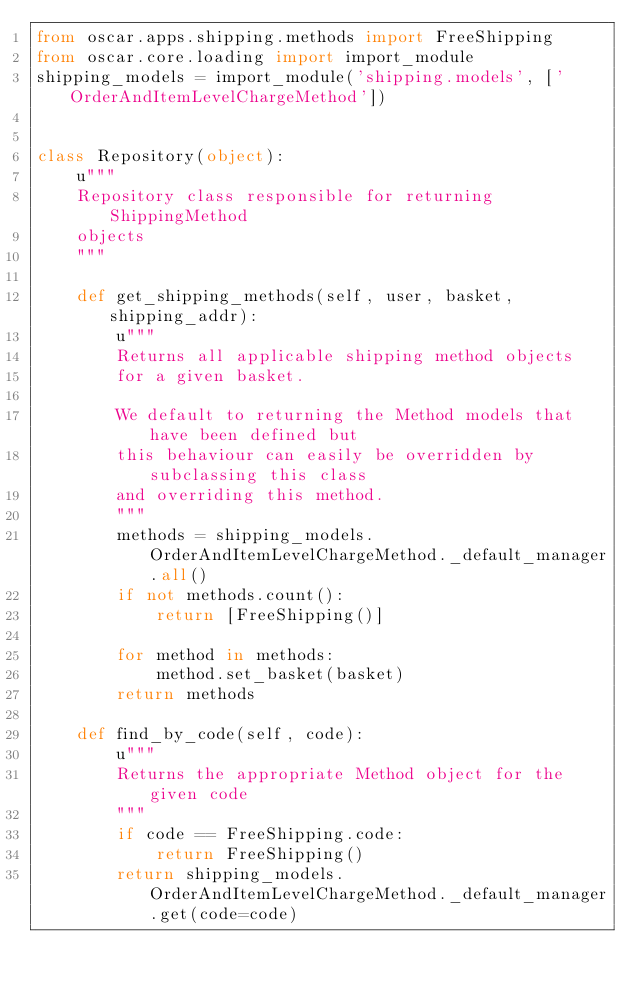<code> <loc_0><loc_0><loc_500><loc_500><_Python_>from oscar.apps.shipping.methods import FreeShipping
from oscar.core.loading import import_module
shipping_models = import_module('shipping.models', ['OrderAndItemLevelChargeMethod'])


class Repository(object):
    u"""
    Repository class responsible for returning ShippingMethod
    objects
    """
    
    def get_shipping_methods(self, user, basket, shipping_addr):
        u"""
        Returns all applicable shipping method objects
        for a given basket.
        
        We default to returning the Method models that have been defined but
        this behaviour can easily be overridden by subclassing this class
        and overriding this method.
        """ 
        methods = shipping_models.OrderAndItemLevelChargeMethod._default_manager.all()
        if not methods.count():
            return [FreeShipping()]
        
        for method in methods:
            method.set_basket(basket)
        return methods

    def find_by_code(self, code):
        u"""
        Returns the appropriate Method object for the given code
        """
        if code == FreeShipping.code:
            return FreeShipping()
        return shipping_models.OrderAndItemLevelChargeMethod._default_manager.get(code=code)          
</code> 